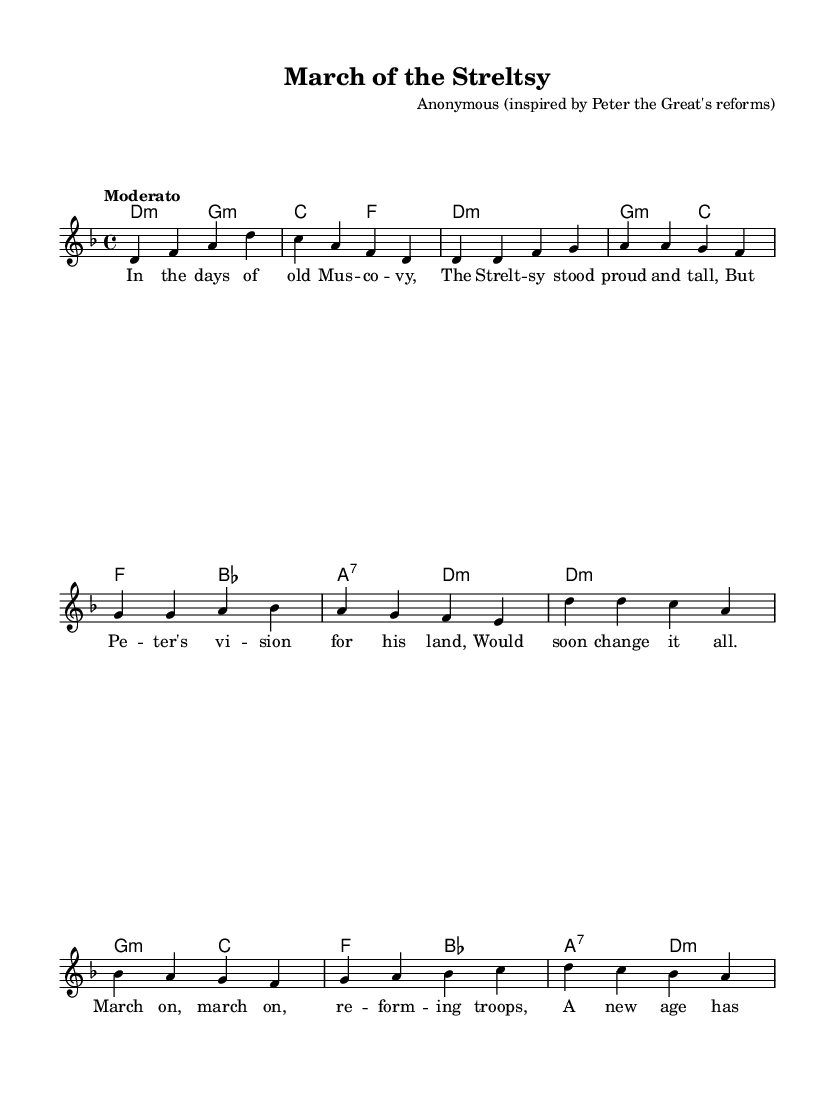What is the key signature of this music? The key signature is D minor, indicated by one flat (B flat).
Answer: D minor What is the time signature of this piece? The time signature displayed in the music is 4/4, meaning there are four beats per measure.
Answer: 4/4 What is the tempo marking for this music? The tempo marking is "Moderato," which indicates a moderate speed for the piece.
Answer: Moderato How many measures are in the chorus section? In the score, there are 4 measures in the chorus section, as counted from the given melody.
Answer: 4 What type of musical form is utilized in the piece? The piece uses a verse-chorus structure, common in folk tunes, alternating between verses and the chorus.
Answer: Verse-chorus What specific military reform inspired the creation of this folk tune? The folk tune was inspired by Peter the Great's military reforms, which aimed to modernize and discipline the Russian army.
Answer: Peter the Great's reforms What historical group do the lyrics refer to that is associated with military efforts in Russia? The lyrics reference the Streltsy, which were the elite troops of the Russian military before Peter's reforms.
Answer: Streltsy 